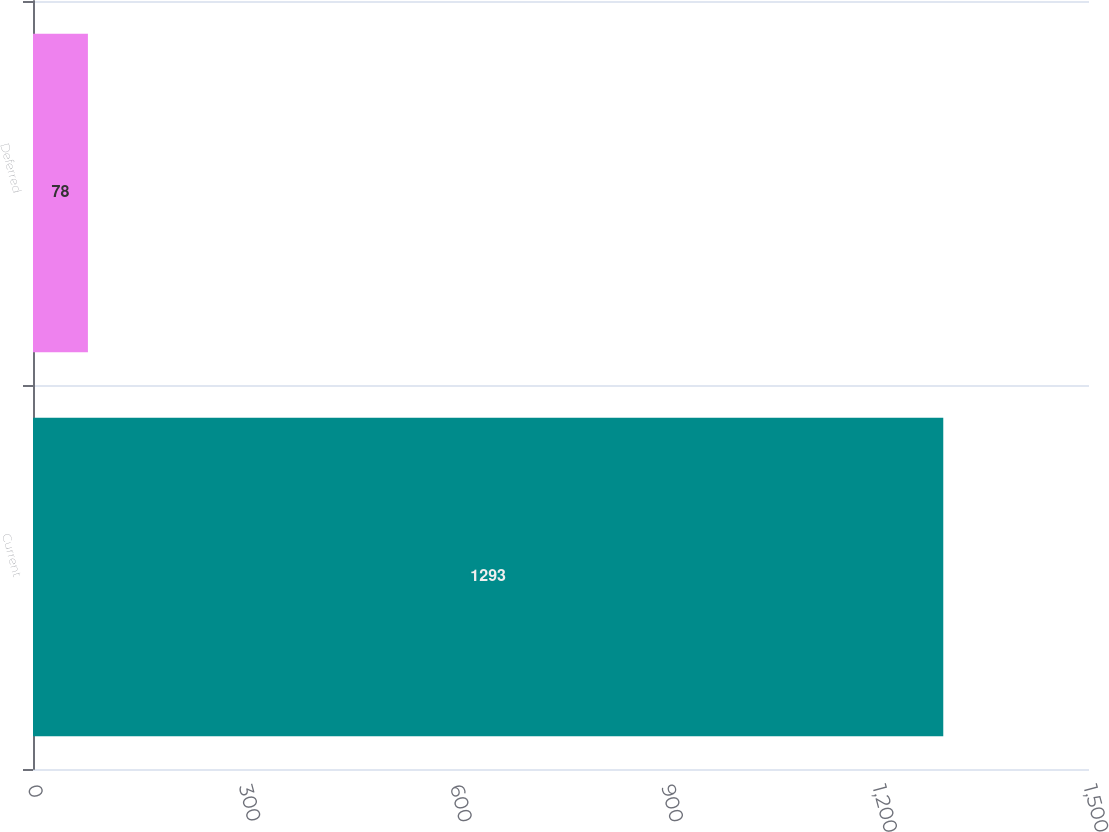<chart> <loc_0><loc_0><loc_500><loc_500><bar_chart><fcel>Current<fcel>Deferred<nl><fcel>1293<fcel>78<nl></chart> 